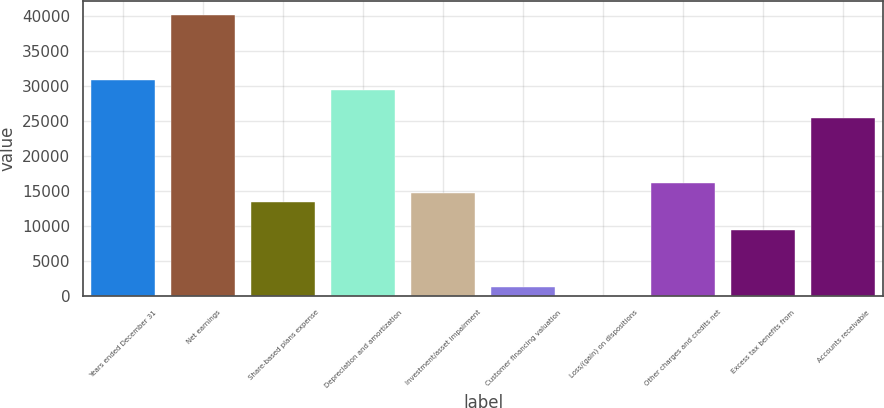Convert chart to OTSL. <chart><loc_0><loc_0><loc_500><loc_500><bar_chart><fcel>Years ended December 31<fcel>Net earnings<fcel>Share-based plans expense<fcel>Depreciation and amortization<fcel>Investment/asset impairment<fcel>Customer financing valuation<fcel>Loss/(gain) on dispositions<fcel>Other charges and credits net<fcel>Excess tax benefits from<fcel>Accounts receivable<nl><fcel>30843.8<fcel>40228<fcel>13416<fcel>29503.2<fcel>14756.6<fcel>1350.6<fcel>10<fcel>16097.2<fcel>9394.2<fcel>25481.4<nl></chart> 